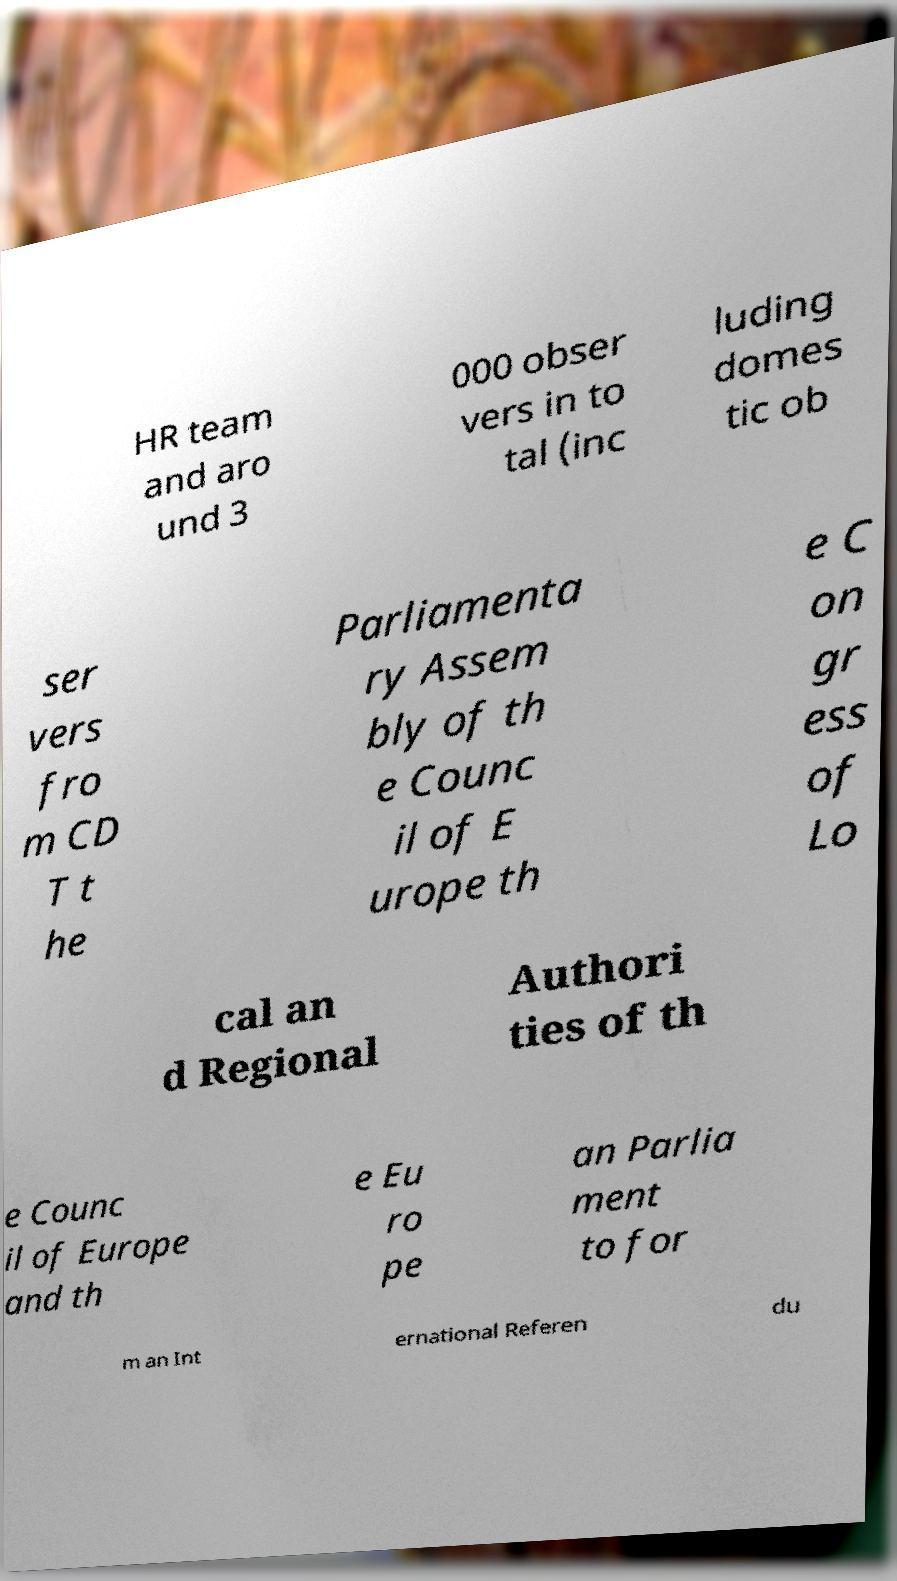Can you accurately transcribe the text from the provided image for me? HR team and aro und 3 000 obser vers in to tal (inc luding domes tic ob ser vers fro m CD T t he Parliamenta ry Assem bly of th e Counc il of E urope th e C on gr ess of Lo cal an d Regional Authori ties of th e Counc il of Europe and th e Eu ro pe an Parlia ment to for m an Int ernational Referen du 